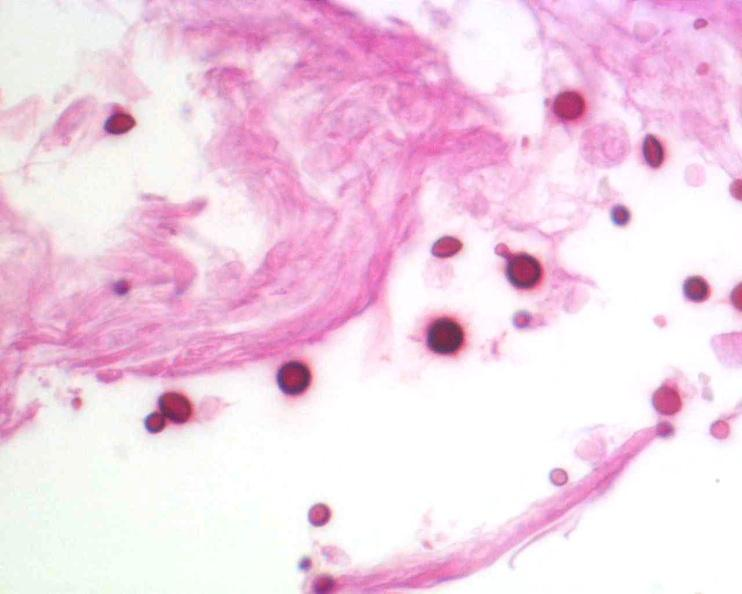s nervous present?
Answer the question using a single word or phrase. Yes 